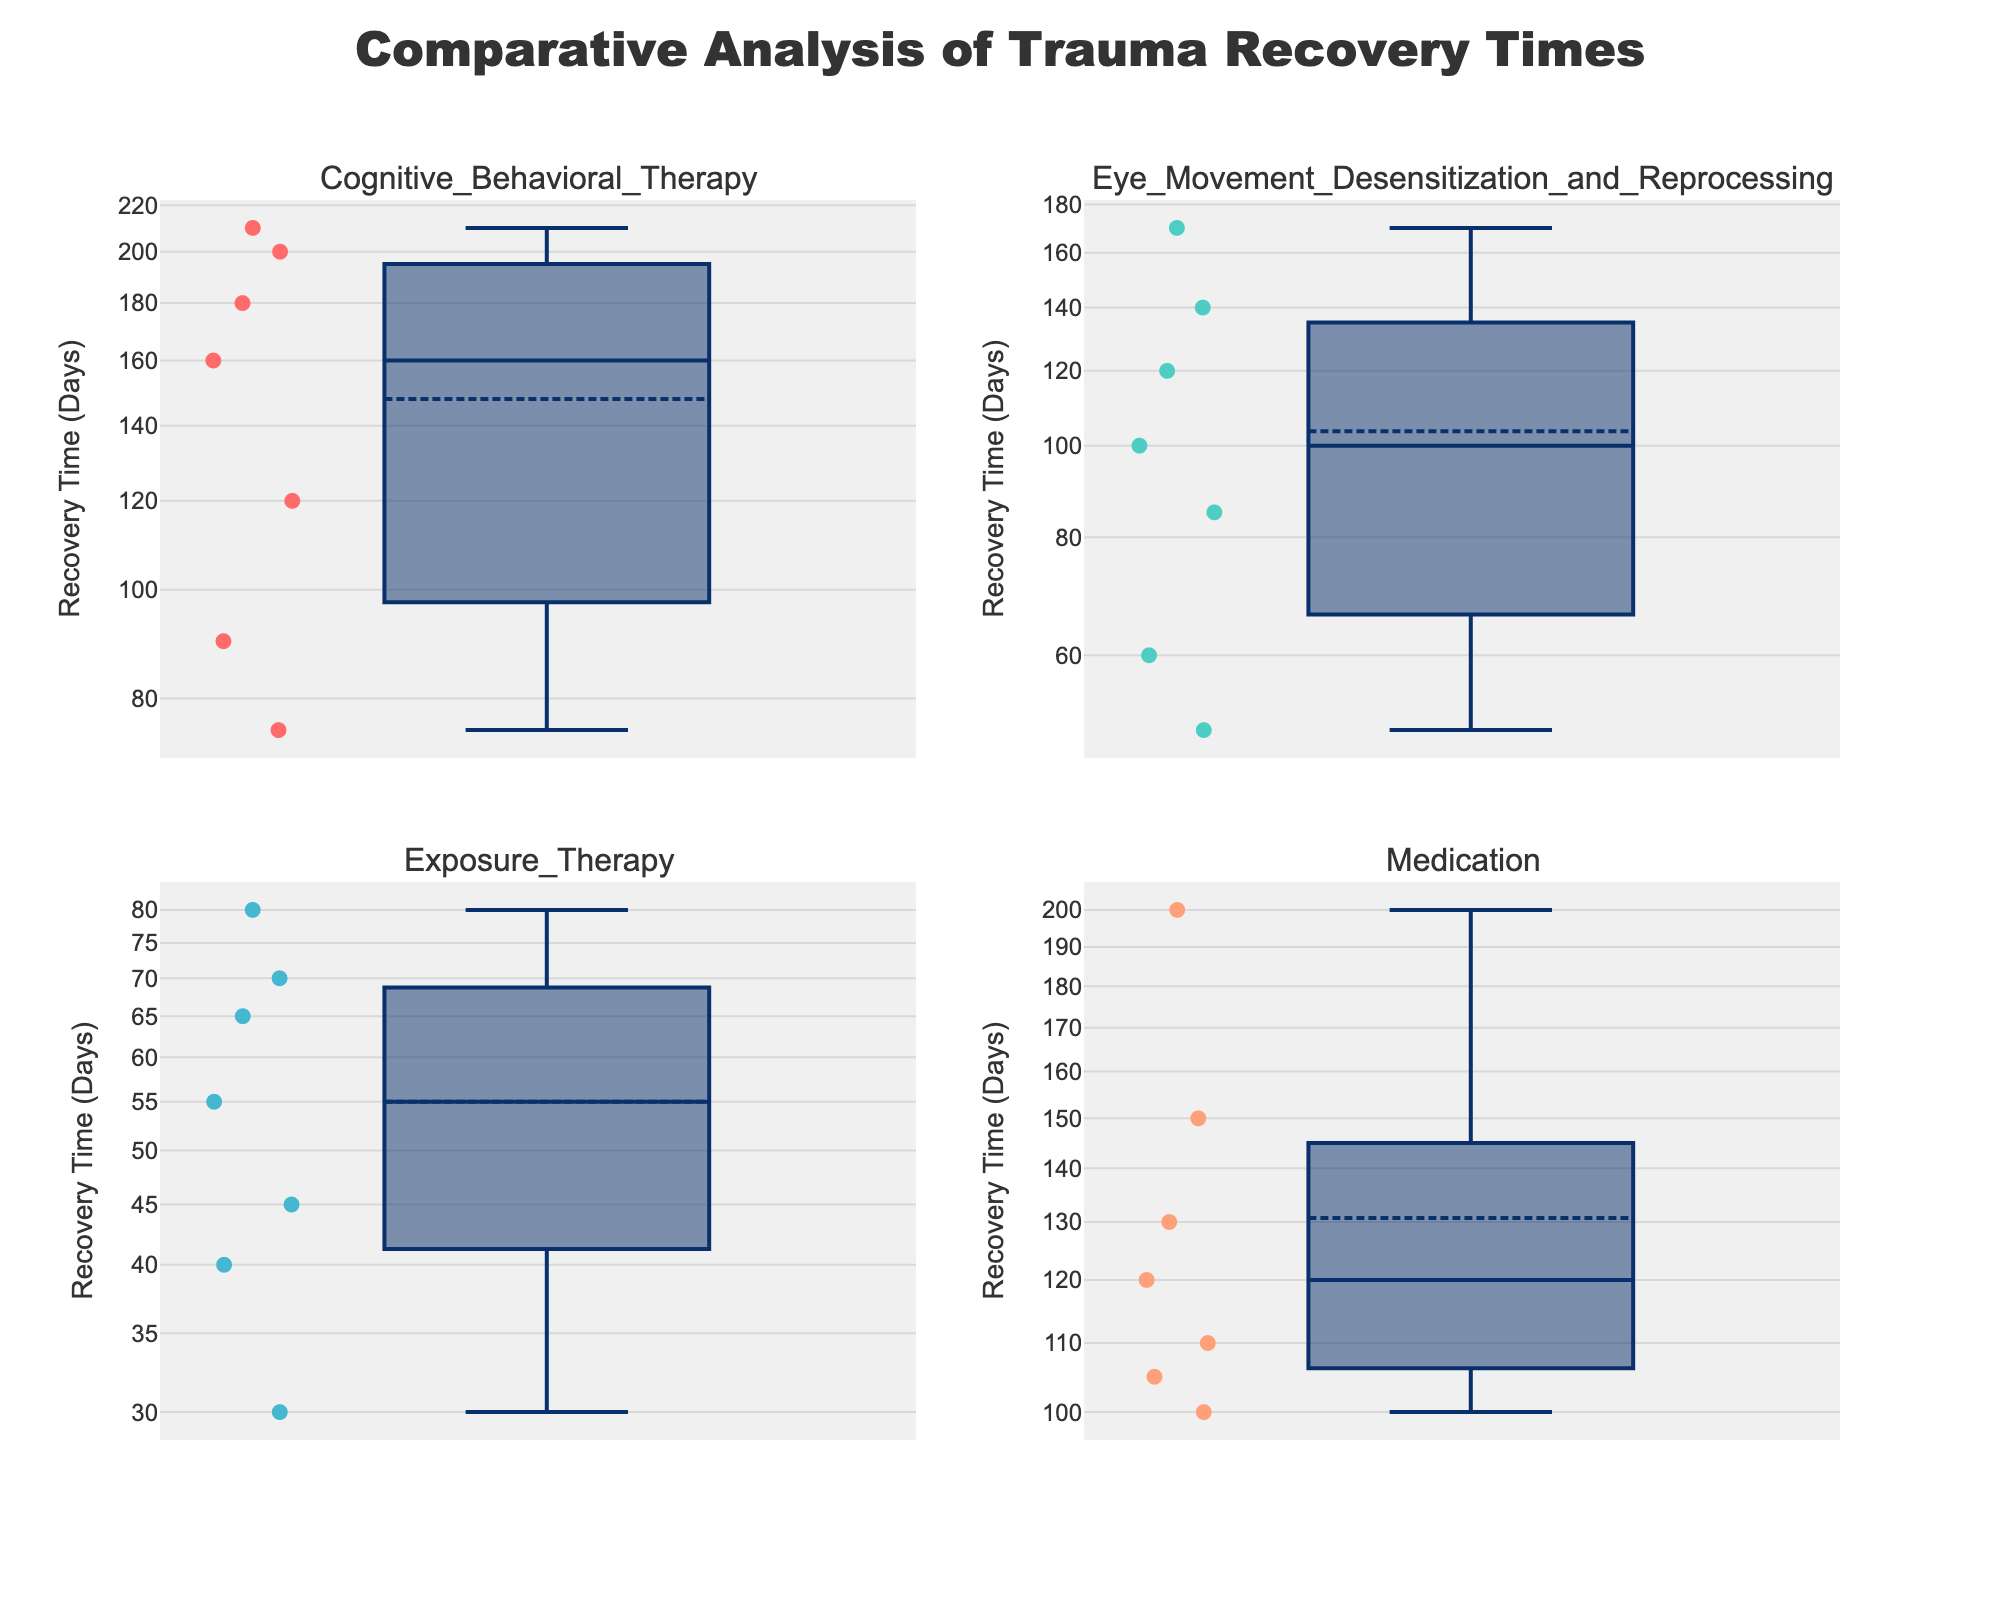What is the title of the figure? Check the main heading at the top of the plot.
Answer: Comparative Analysis of Trauma Recovery Times How many subplots are there in the figure? Count the individual plot areas.
Answer: Four Which treatment method has a subplot in the top right? Look at the subplot titles.
Answer: Eye Movement Desensitization and Reprocessing Which treatment method shows the shortest recovery time? Find the smallest value in each subplot on the y-axis and compare.
Answer: Exposure Therapy What is the longest recovery time for Cognitive Behavioral Therapy? Look at the y-axis values in the subplot for Cognitive Behavioral Therapy.
Answer: 210 days Which treatment method has the highest median recovery time? Look for the median indicator (usually a line within the box) in each subplot and compare.
Answer: Cognitive Behavioral Therapy What's the range of recovery times for Medication? Identify the minimum and maximum y-values in the Medication subplot, then calculate the difference.
Answer: 30 to 200 days For Cognitive Behavioral Therapy, what is the difference between the 75th percentile and the median recovery time? Determine the values of the 75th percentile (top of the box) and the median (line inside the box), then compute the difference.
Answer: 180 - 120 = 60 days Which two treatment methods have overlapping ranges of recovery times? Compare the y-axis ranges in the subplots.
Answer: Eye Movement Desensitization and Reprocessing and Medication In which subplot does the majority of the data points fall below 100 days? Observe the distribution of points in each subplot in relation to the 100-day mark on the y-axis.
Answer: Exposure Therapy 